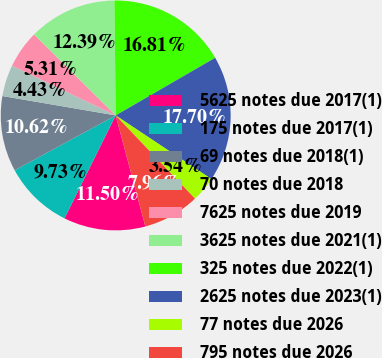<chart> <loc_0><loc_0><loc_500><loc_500><pie_chart><fcel>5625 notes due 2017(1)<fcel>175 notes due 2017(1)<fcel>69 notes due 2018(1)<fcel>70 notes due 2018<fcel>7625 notes due 2019<fcel>3625 notes due 2021(1)<fcel>325 notes due 2022(1)<fcel>2625 notes due 2023(1)<fcel>77 notes due 2026<fcel>795 notes due 2026<nl><fcel>11.5%<fcel>9.73%<fcel>10.62%<fcel>4.43%<fcel>5.31%<fcel>12.39%<fcel>16.81%<fcel>17.7%<fcel>3.54%<fcel>7.96%<nl></chart> 